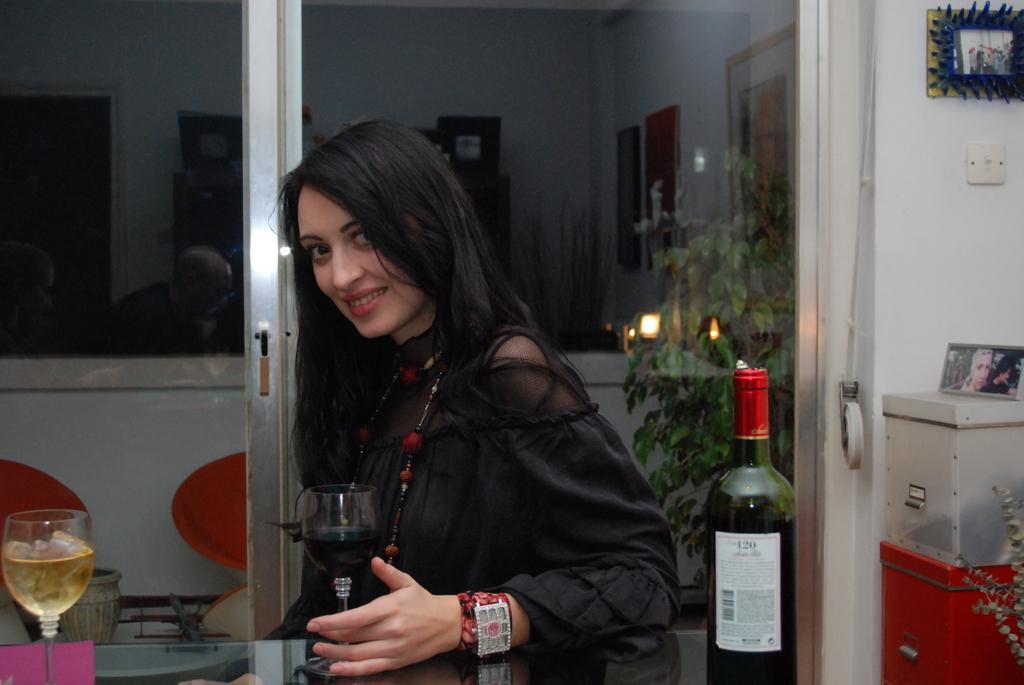Describe this image in one or two sentences. This picture is taken in a house. In the center of the picture there is a woman in black dress, she is smiling. In the foreground there is a table, on the table there is a wine bottle. In the center there is a glass. On the left there is another glass. To the left there are chairs. On the right there is a glass door and a plant. To the top right there is a frame and box. In the background there is a wall, frames and door. 